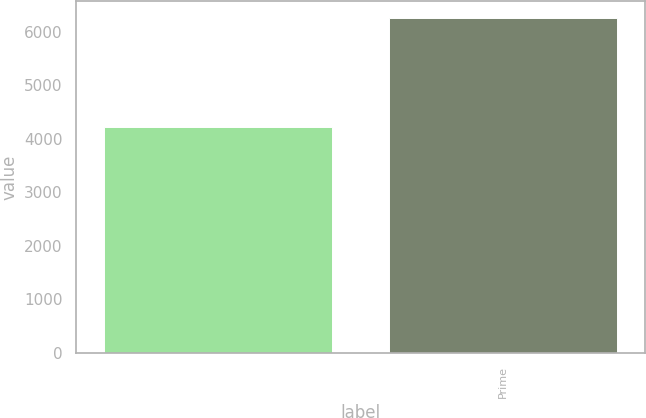Convert chart to OTSL. <chart><loc_0><loc_0><loc_500><loc_500><bar_chart><ecel><fcel>Prime<nl><fcel>4221<fcel>6258<nl></chart> 